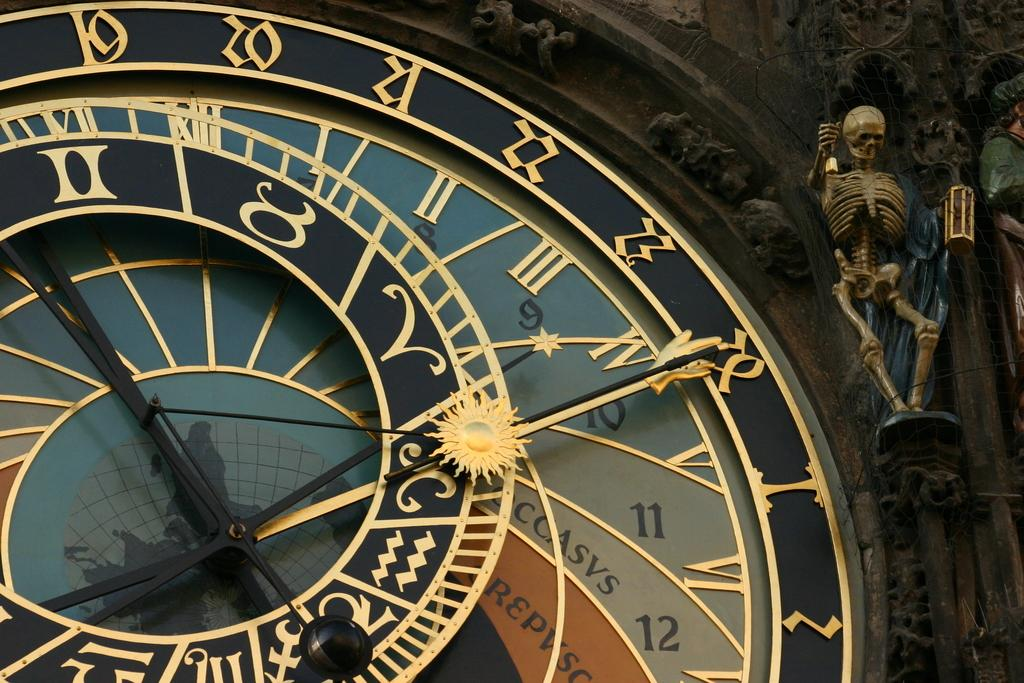<image>
Describe the image concisely. Number 19 through 28, and numbers one and two are seen on a clock, with a skeleton hanging to the top, right corner of it. 